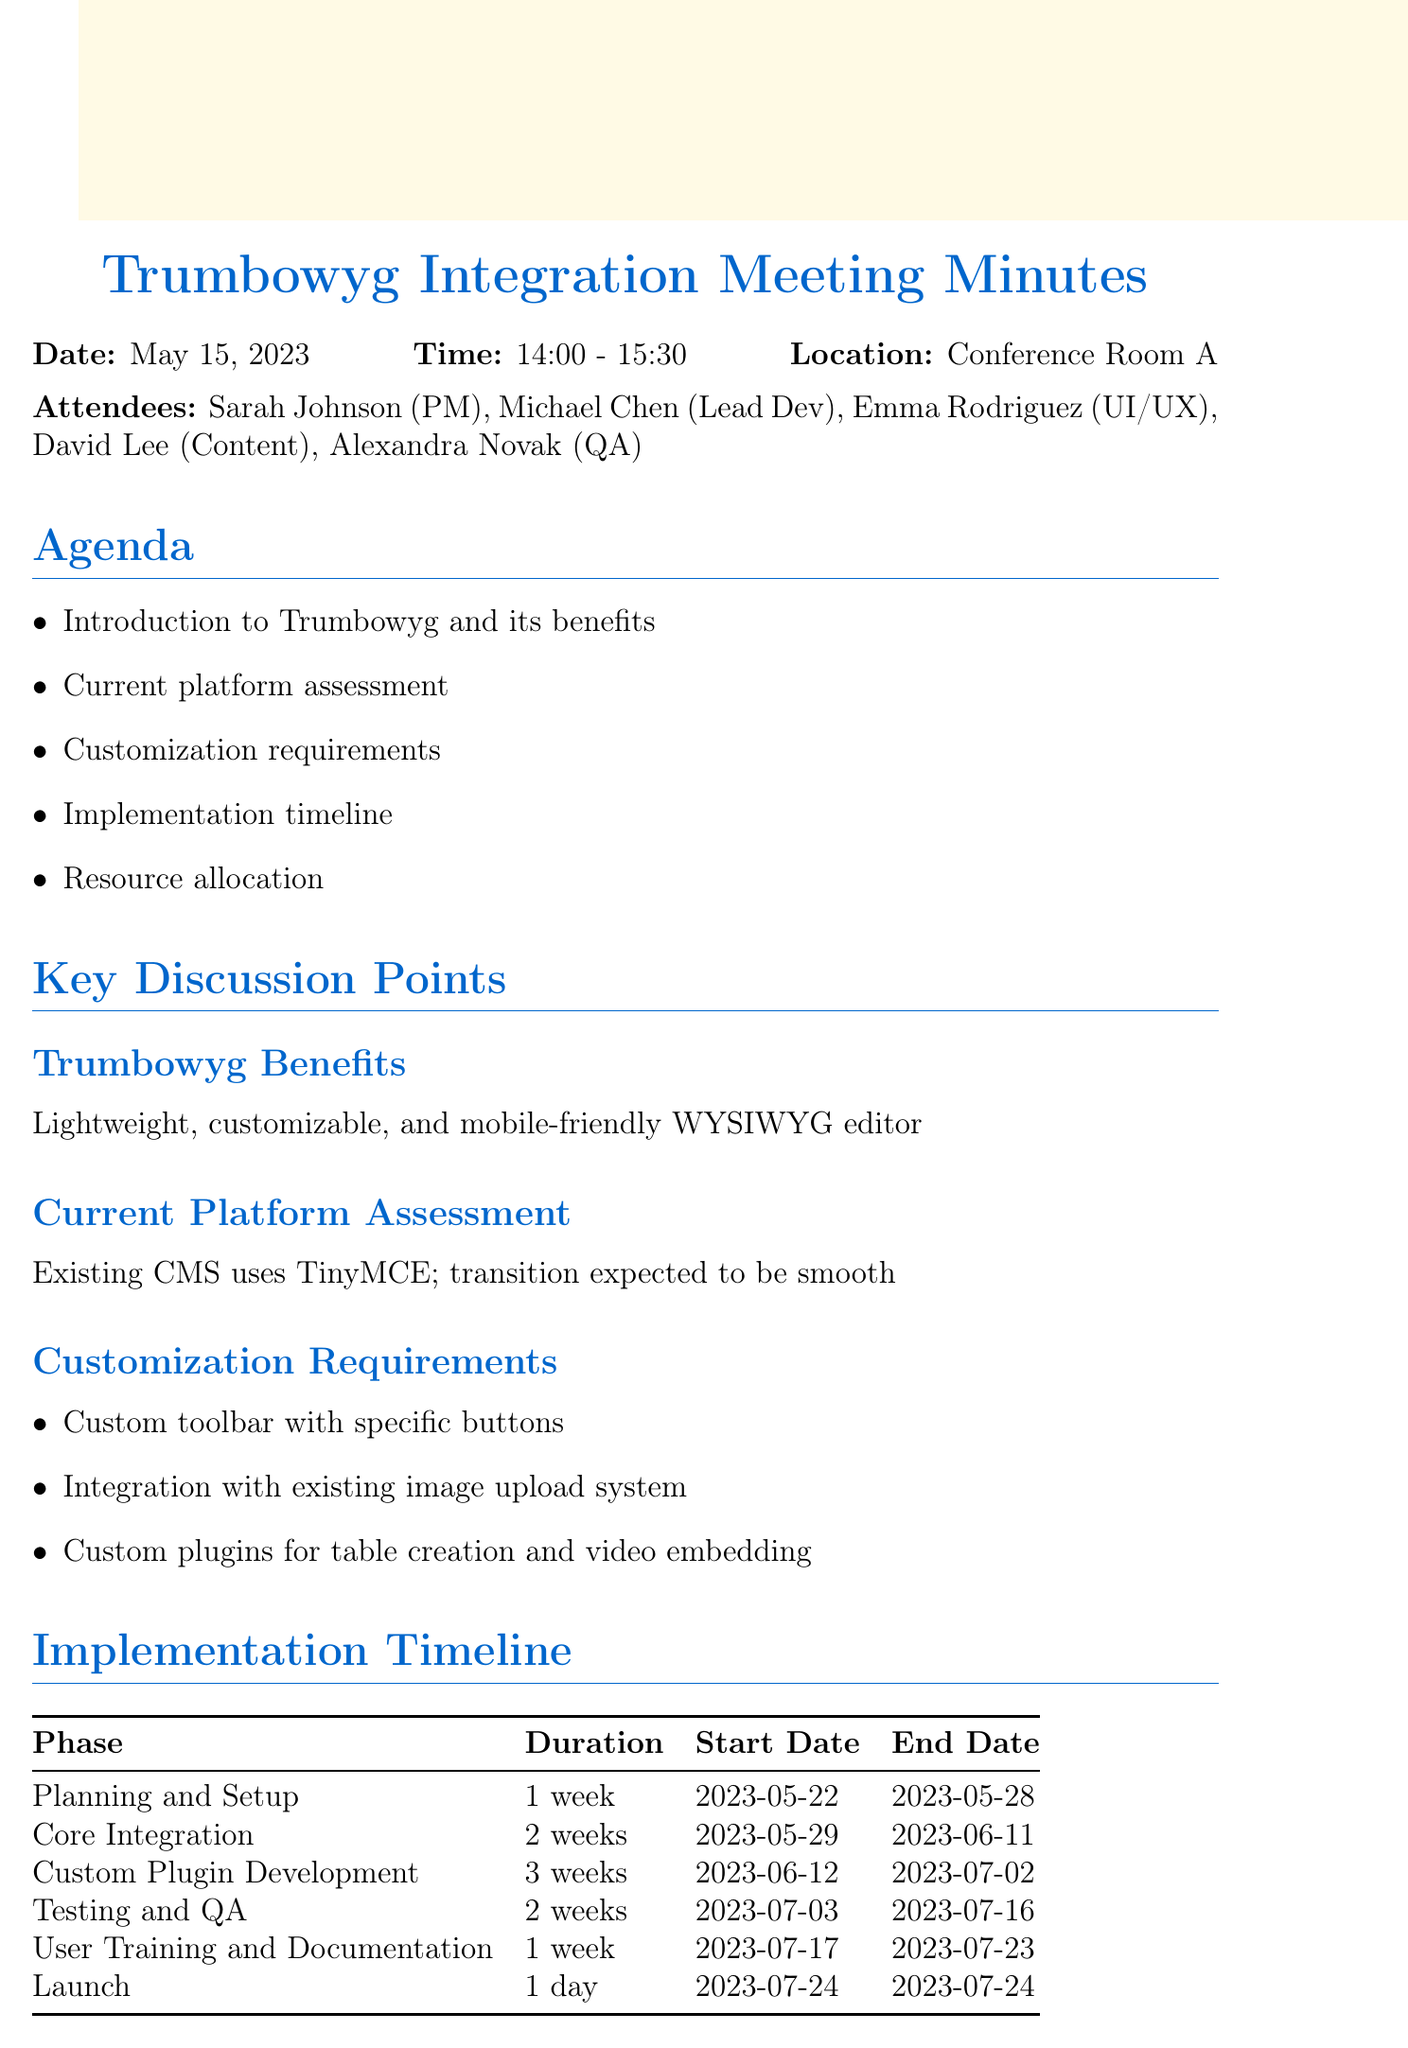What date was the meeting held? The document states the meeting date is May 15, 2023.
Answer: May 15, 2023 Who is the Lead Developer? The resource allocation section lists Michael Chen as the Lead Developer.
Answer: Michael Chen What is the duration for the Core Integration phase? The implementation timeline indicates that Core Integration lasts for 2 weeks.
Answer: 2 weeks What phase starts on July 17, 2023? The implementation timeline shows that the User Training and Documentation phase starts on July 17, 2023.
Answer: User Training and Documentation How many frontend developers are allocated to the project? The resource allocation notes that there are 2 frontend developers assigned.
Answer: 2 What is the primary benefit of Trumbowyg mentioned in the document? The benefits section states that Trumbowyg is a lightweight, customizable, and mobile-friendly WYSIWYG editor.
Answer: Lightweight Who is responsible for preparing the content migration plan? The action items specify that David is tasked with preparing the content migration plan.
Answer: David When is the next meeting scheduled? The document indicates that the next meeting is scheduled for May 22, 2023.
Answer: May 22, 2023 How long is the Testing and QA phase? The implementation timeline specifies that the Testing and QA phase lasts for 2 weeks.
Answer: 2 weeks 